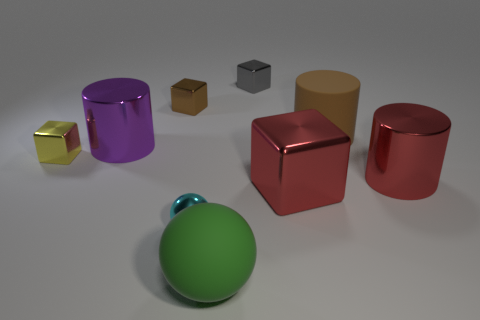Subtract all large purple metal cylinders. How many cylinders are left? 2 Subtract all red cylinders. How many cylinders are left? 2 Subtract all blocks. How many objects are left? 5 Subtract all gray spheres. How many brown blocks are left? 1 Add 4 green matte balls. How many green matte balls are left? 5 Add 3 brown metal blocks. How many brown metal blocks exist? 4 Subtract 1 cyan balls. How many objects are left? 8 Subtract 1 balls. How many balls are left? 1 Subtract all cyan cubes. Subtract all red balls. How many cubes are left? 4 Subtract all big red metallic objects. Subtract all brown shiny blocks. How many objects are left? 6 